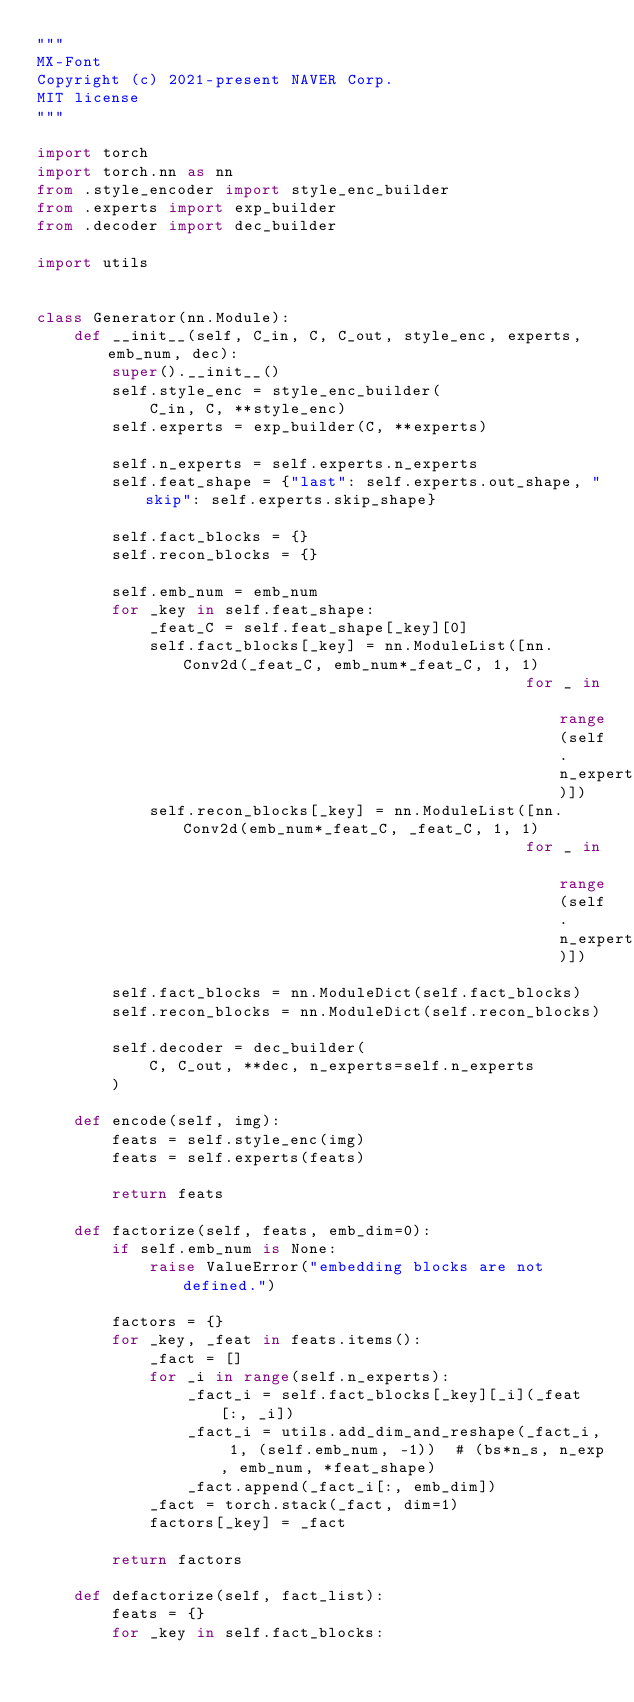Convert code to text. <code><loc_0><loc_0><loc_500><loc_500><_Python_>"""
MX-Font
Copyright (c) 2021-present NAVER Corp.
MIT license
"""

import torch
import torch.nn as nn
from .style_encoder import style_enc_builder
from .experts import exp_builder
from .decoder import dec_builder

import utils


class Generator(nn.Module):
    def __init__(self, C_in, C, C_out, style_enc, experts, emb_num, dec):
        super().__init__()
        self.style_enc = style_enc_builder(
            C_in, C, **style_enc)
        self.experts = exp_builder(C, **experts)

        self.n_experts = self.experts.n_experts
        self.feat_shape = {"last": self.experts.out_shape, "skip": self.experts.skip_shape}

        self.fact_blocks = {}
        self.recon_blocks = {}

        self.emb_num = emb_num
        for _key in self.feat_shape:
            _feat_C = self.feat_shape[_key][0]
            self.fact_blocks[_key] = nn.ModuleList([nn.Conv2d(_feat_C, emb_num*_feat_C, 1, 1)
                                                    for _ in range(self.n_experts)])
            self.recon_blocks[_key] = nn.ModuleList([nn.Conv2d(emb_num*_feat_C, _feat_C, 1, 1)
                                                    for _ in range(self.n_experts)])

        self.fact_blocks = nn.ModuleDict(self.fact_blocks)
        self.recon_blocks = nn.ModuleDict(self.recon_blocks)

        self.decoder = dec_builder(
            C, C_out, **dec, n_experts=self.n_experts
        )

    def encode(self, img):
        feats = self.style_enc(img)
        feats = self.experts(feats)

        return feats

    def factorize(self, feats, emb_dim=0):
        if self.emb_num is None:
            raise ValueError("embedding blocks are not defined.")

        factors = {}
        for _key, _feat in feats.items():
            _fact = []
            for _i in range(self.n_experts):
                _fact_i = self.fact_blocks[_key][_i](_feat[:, _i])
                _fact_i = utils.add_dim_and_reshape(_fact_i, 1, (self.emb_num, -1))  # (bs*n_s, n_exp, emb_num, *feat_shape)
                _fact.append(_fact_i[:, emb_dim])
            _fact = torch.stack(_fact, dim=1)
            factors[_key] = _fact

        return factors

    def defactorize(self, fact_list):
        feats = {}
        for _key in self.fact_blocks:</code> 